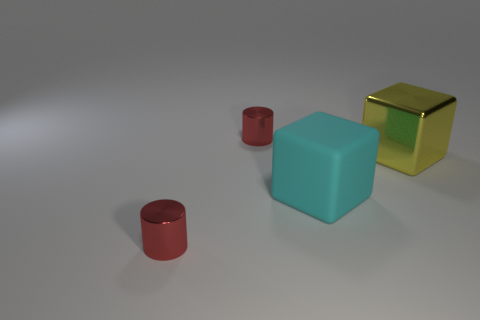Are there fewer large yellow things than small cylinders?
Offer a terse response. Yes. There is a rubber cube; is its color the same as the shiny cylinder behind the large yellow object?
Provide a succinct answer. No. Are there the same number of metal cylinders on the right side of the big rubber cube and tiny cylinders that are behind the large yellow object?
Provide a short and direct response. No. How many yellow metallic things are the same shape as the matte object?
Provide a short and direct response. 1. Are there any rubber things?
Your answer should be compact. Yes. Do the yellow block and the tiny cylinder that is in front of the large cyan matte object have the same material?
Offer a very short reply. Yes. There is another yellow cube that is the same size as the matte cube; what is its material?
Keep it short and to the point. Metal. Are there any small purple things made of the same material as the big cyan block?
Your answer should be compact. No. Are there any red metal things that are in front of the red cylinder left of the small red metal cylinder behind the large yellow metal block?
Keep it short and to the point. No. What shape is the shiny thing that is the same size as the matte block?
Offer a terse response. Cube. 